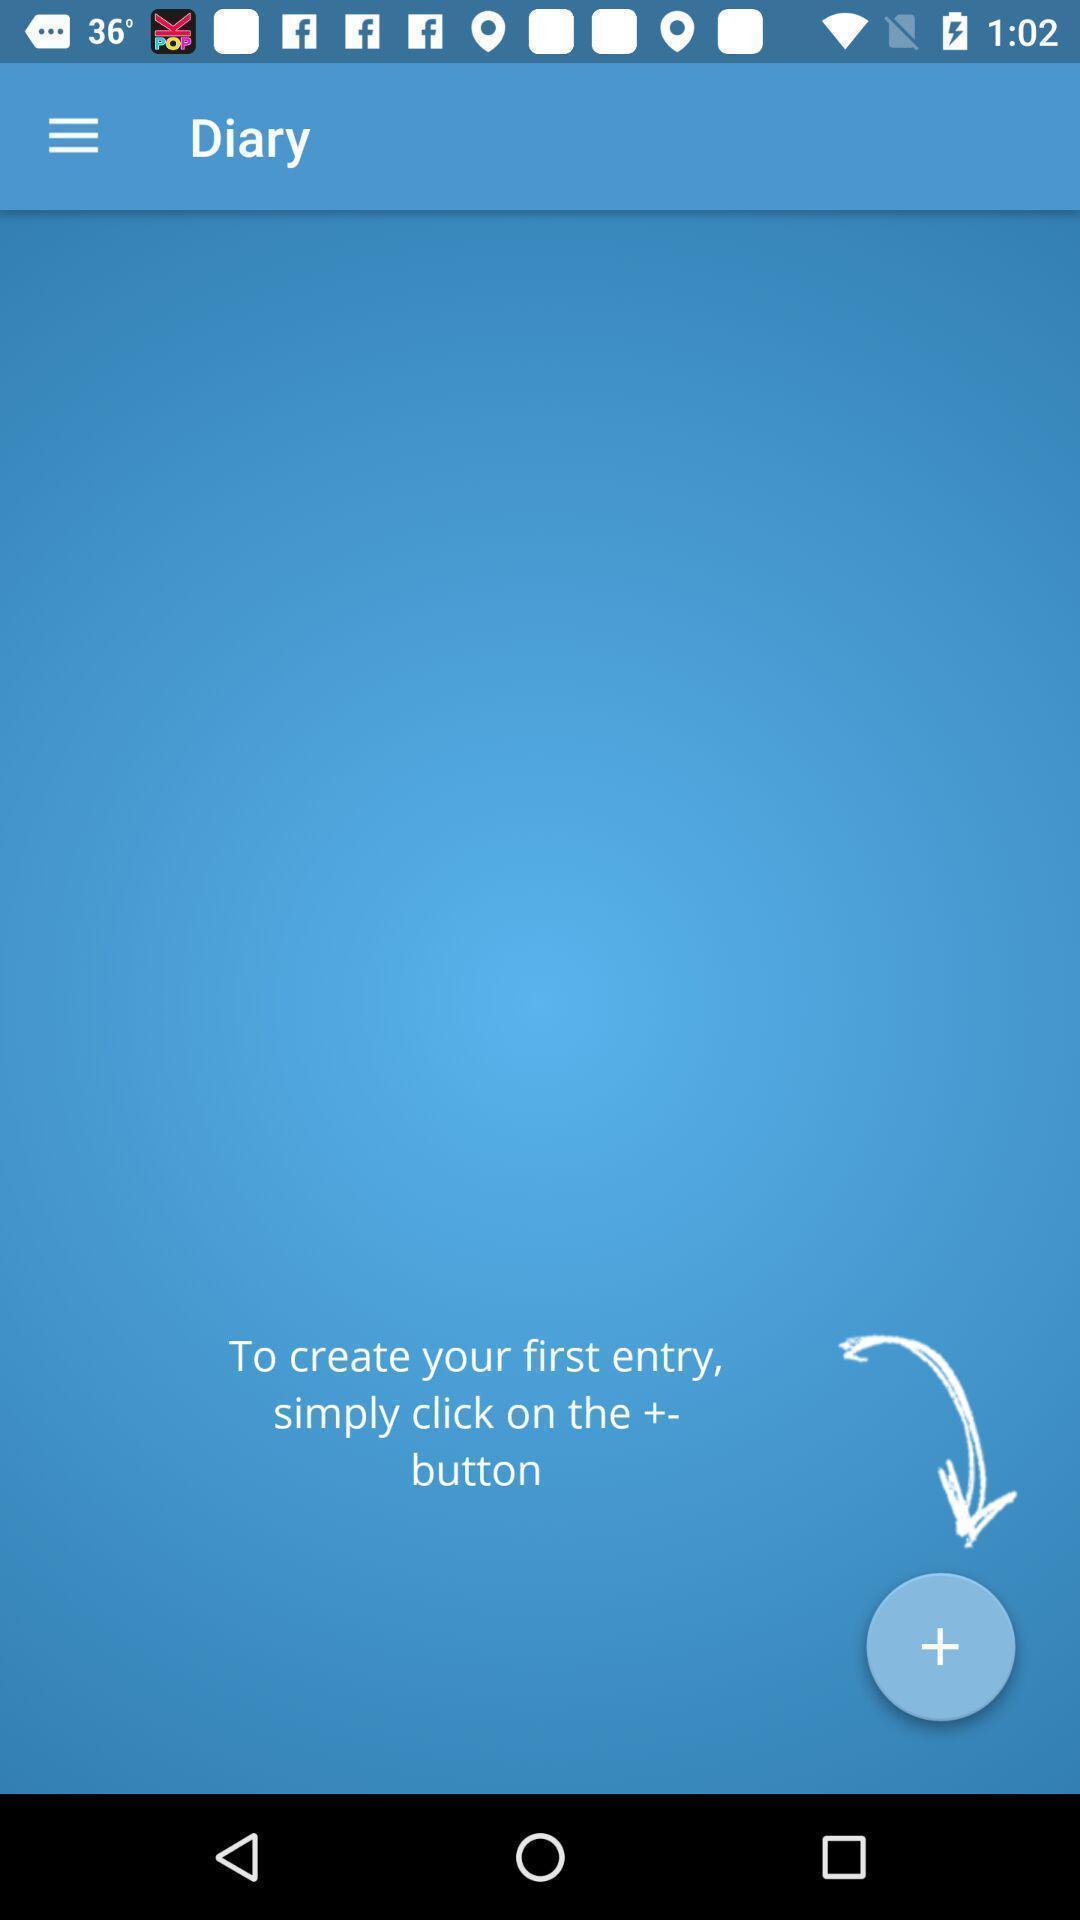Provide a description of this screenshot. Page to record the diabetes data. 